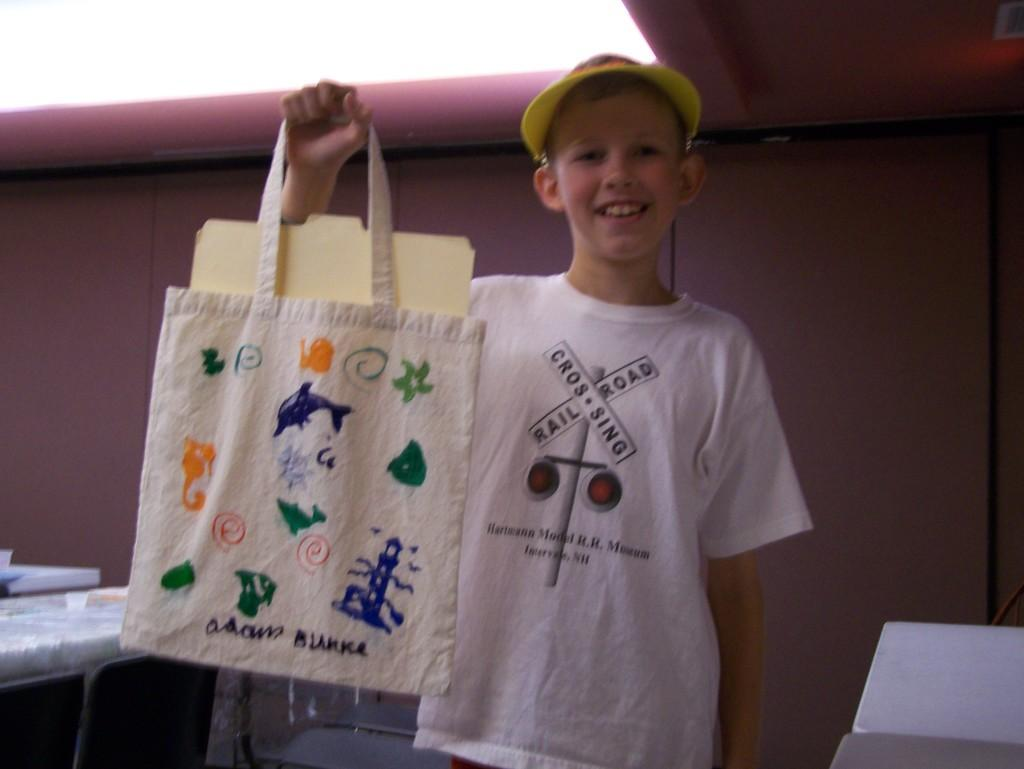Who is the main subject in the image? There is a boy in the image. What is the boy holding in the image? The boy is holding a bag. What is inside the bag that the boy is holding? The bag contains documents. What type of wheel can be seen attached to the bag in the image? There is no wheel attached to the bag in the image. What kind of drug is the boy offering to someone in the image? There is no drug or offering present in the image; the boy is simply holding a bag containing documents. 